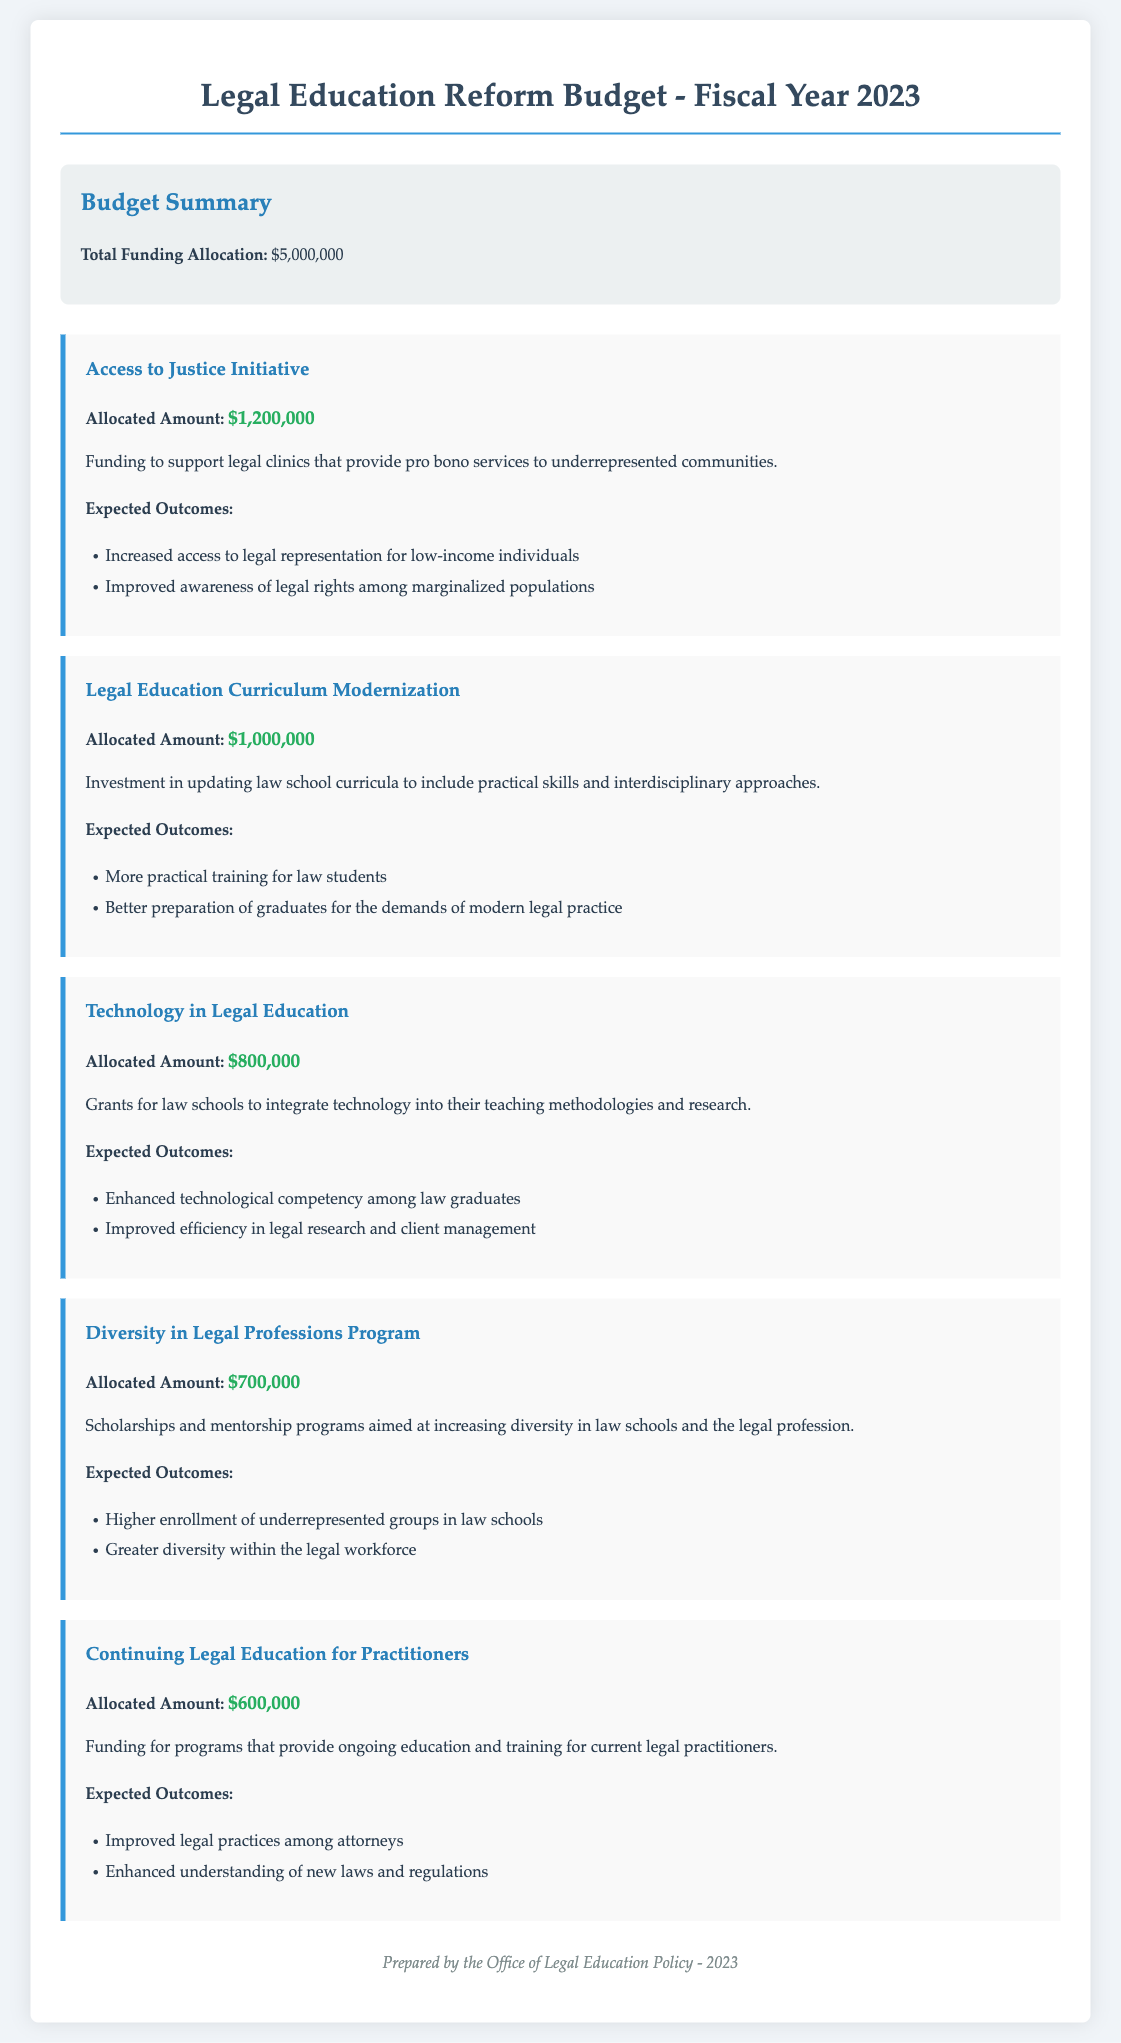what is the total funding allocation? The total funding allocation is stated in the budget summary section of the document.
Answer: $5,000,000 how much is allocated to the Access to Justice Initiative? The allocated amount for the Access to Justice Initiative is found under the program details.
Answer: $1,200,000 what is one expected outcome of the Legal Education Curriculum Modernization? This expected outcome is listed in the outcomes section of that program.
Answer: More practical training for law students how much funding is dedicated to the Technology in Legal Education program? The funding amount for the Technology in Legal Education program can be found in its respective section.
Answer: $800,000 which program focuses on increasing diversity in law schools? The program name is specifically mentioned that highlights its focus on diversity in legal professions.
Answer: Diversity in Legal Professions Program what is the total funding allocation for Continuing Legal Education for Practitioners? This amount is given in the program details section of the budget.
Answer: $600,000 what is the main goal of the Diversity in Legal Professions Program? The goal is specifically outlined in the description of the program.
Answer: Increasing diversity in law schools and the legal profession how much is allocated to the Legal Education Curriculum Modernization program? The document explicitly states the amount allocated for this program.
Answer: $1,000,000 